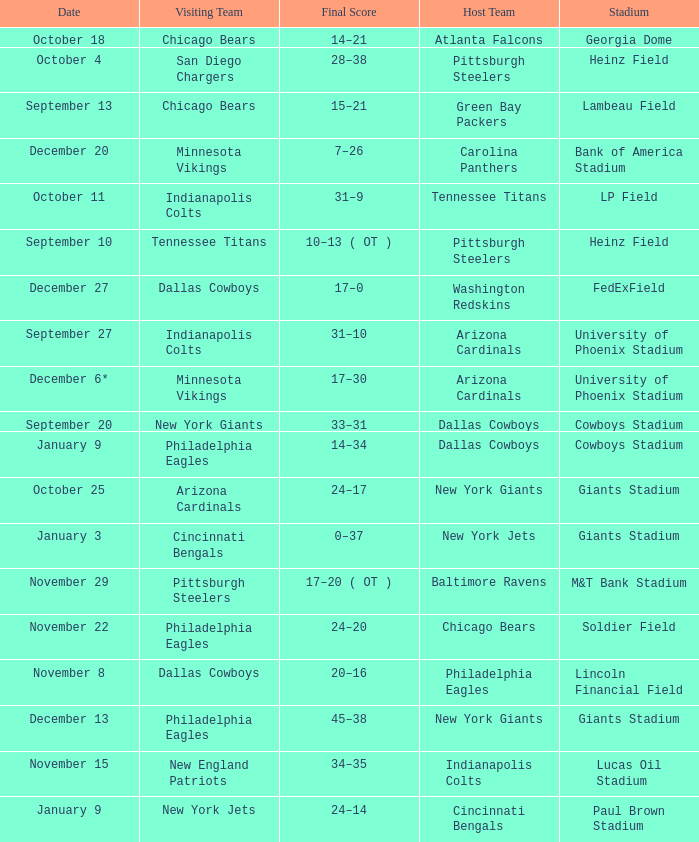Tell me the host team for giants stadium and visiting of cincinnati bengals New York Jets. 